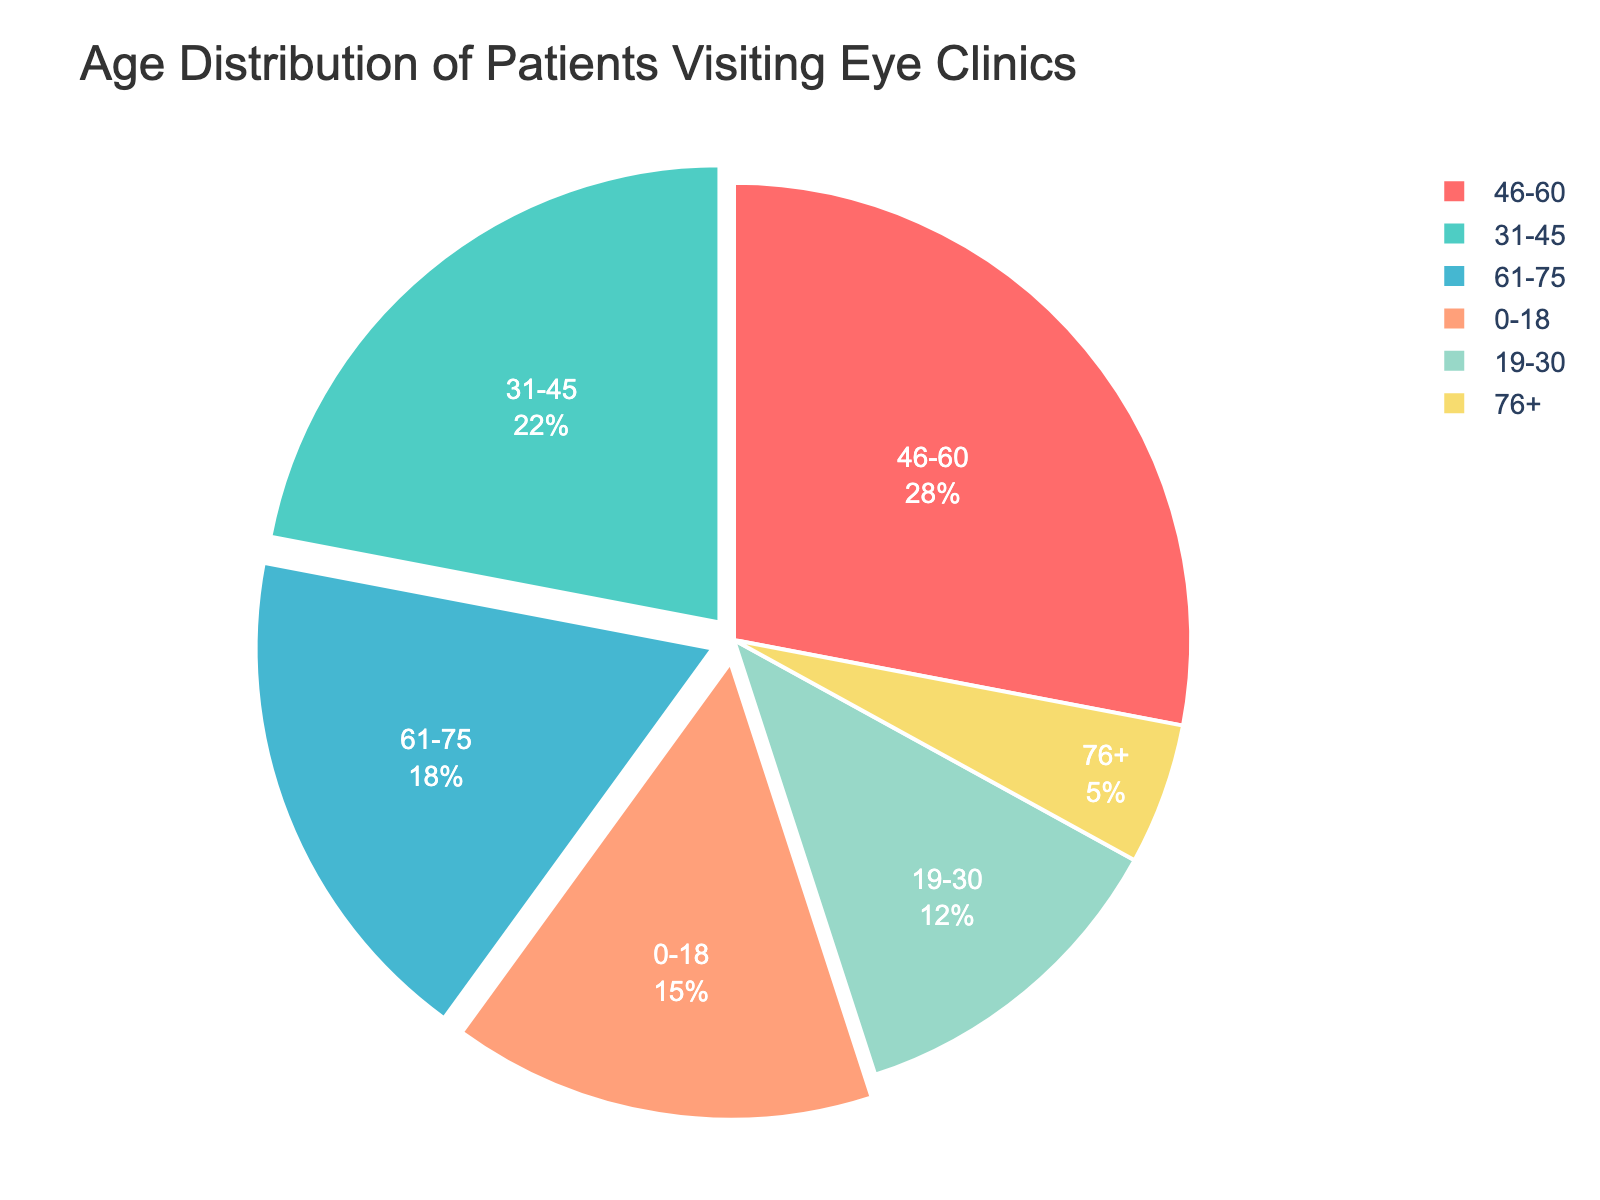What age group has the highest percentage of patients visiting the eye clinic? Looking at the pie chart, the largest segment corresponds to the age group with the highest percentage. It's the largest segment in the chart.
Answer: 46-60 What is the total percentage of patients aged 31-45 and 46-60 combined? Add the percentages of the age groups 31-45 and 46-60. That is 22% + 28%.
Answer: 50% Which age group has the smallest percentage of patients visiting the eye clinic? Identify the smallest segment in the pie chart, which corresponds to the age group with the smallest percentage.
Answer: 76+ How much larger is the percentage of patients aged 61-75 compared to those aged 76+? Subtract the percentage of the 76+ age group from the percentage of the 61-75 age group, i.e., 18% - 5%.
Answer: 13% What is the combined percentage of patients aged 0-18 and 19-30? Add the percentages of the age groups 0-18 and 19-30. That is 15% + 12%.
Answer: 27% Which age group has a higher percentage of patients: 31-45 or 61-75? Compare the percentages of the 31-45 age group (22%) and the 61-75 age group (18%). 22% is greater than 18%.
Answer: 31-45 What is the total percentage of patients older than 45 years? Sum the percentages of the 46-60, 61-75, and 76+ age groups. That is 28% + 18% + 5%.
Answer: 51% How much larger is the percentage of the 46-60 age group compared to the 19-30 age group? Subtract the percentage of the 19-30 age group from the 46-60 age group, i.e., 28% - 12%.
Answer: 16% What is the average percentage of patients in the age groups 0-18, 19-30, and 31-45? Add the percentages of the 0-18, 19-30, and 31-45 age groups, then divide by 3. That’s (15% + 12% + 22%) / 3.
Answer: 16.33% Which of the following groups have the closest percentages: 0-18 and 19-30, or 19-30 and 61-75? Compare the differences between each pair's percentages. Differences are 15% - 12% = 3% and 18% - 12% = 6%.
Answer: 0-18 and 19-30 